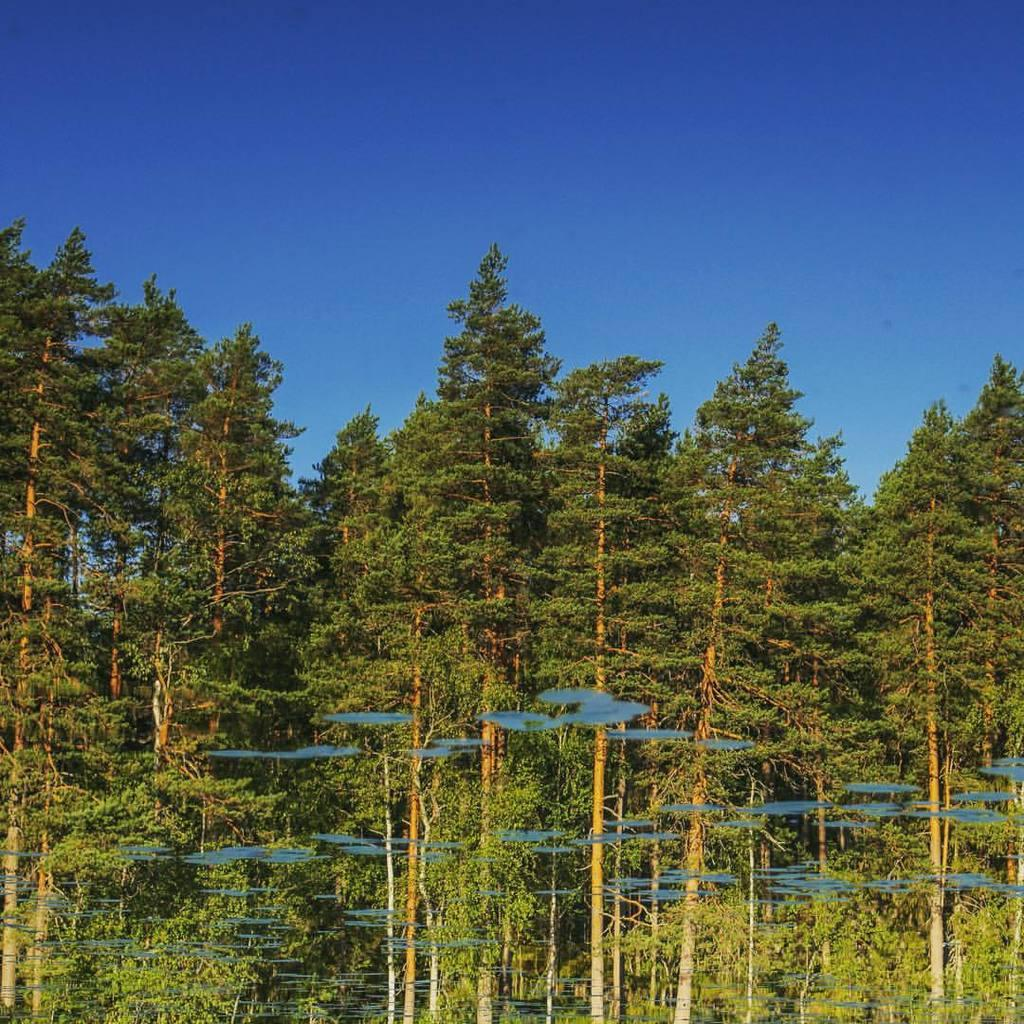What type of vegetation is in the foreground of the image? There are trees in the foreground of the image. What is visible at the top of the image? The sky is visible at the top of the image. What type of disease is affecting the trees in the image? There is no indication of any disease affecting the trees in the image; they appear to be healthy. What type of seed is present in the image? There is no mention of any seeds in the image; it only features trees and the sky. 